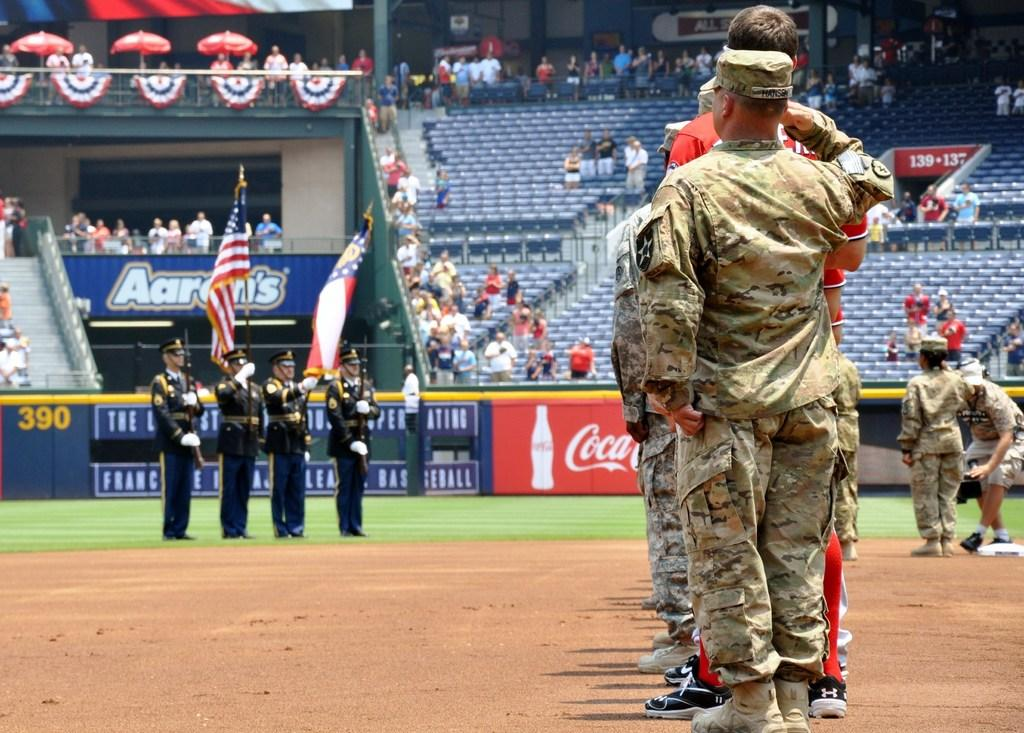<image>
Relay a brief, clear account of the picture shown. The blue wall around the ball field has the number 390 on it in yellow. 